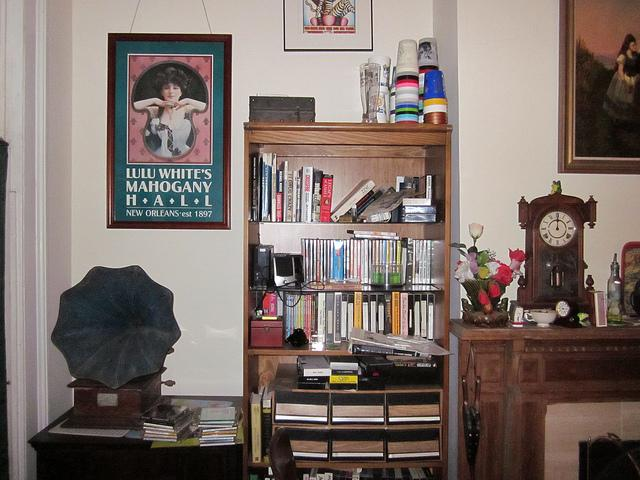Where is this bookshelf located? Please explain your reasoning. home. A bookshelf is in a room with a desk and personal items. homes are filled with personal items. 